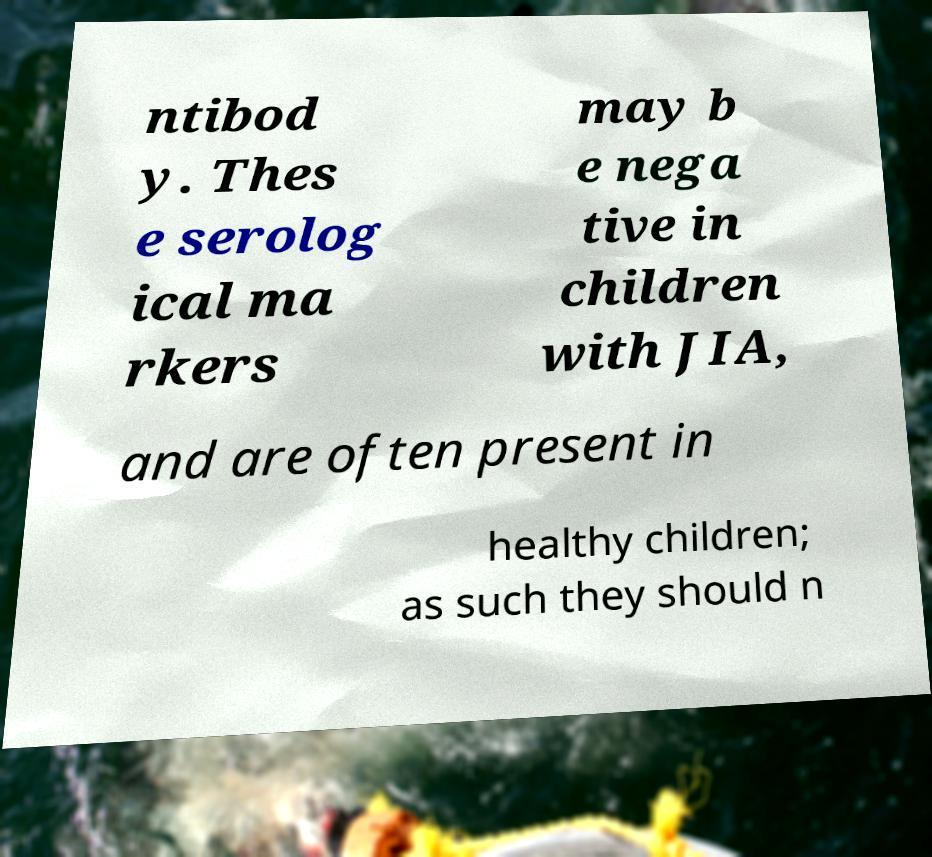Could you extract and type out the text from this image? ntibod y. Thes e serolog ical ma rkers may b e nega tive in children with JIA, and are often present in healthy children; as such they should n 